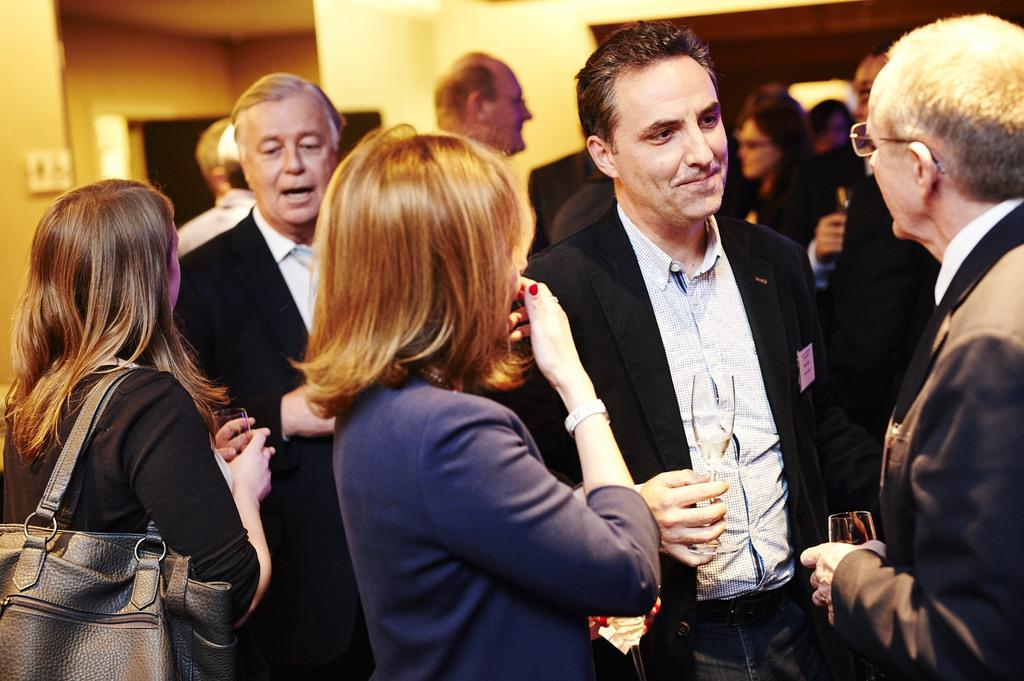What is the main subject of the image? The main subject of the image is a group of people. What are the people in the image doing? The people are standing and holding wine glasses. Can you describe the background of the image? The background of the image is blurred. How many horses can be seen in the image? There are no horses present in the image. What type of teeth are visible in the image? There are no teeth visible in the image. 